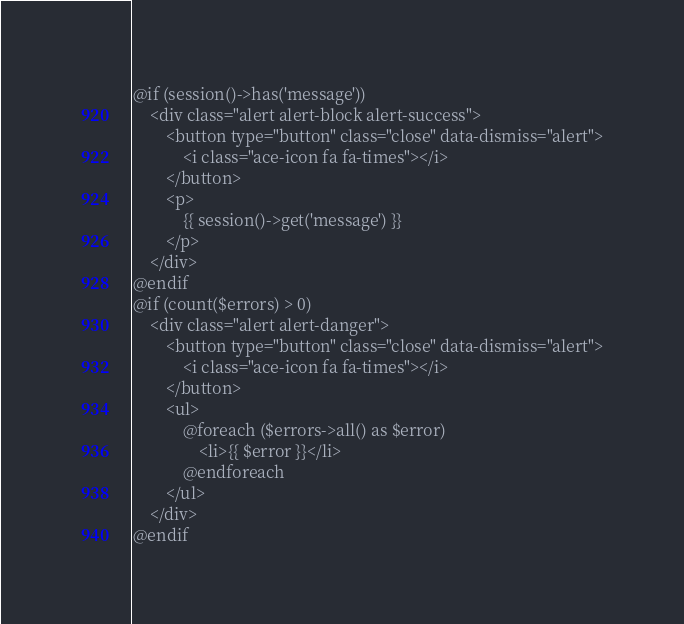<code> <loc_0><loc_0><loc_500><loc_500><_PHP_>@if (session()->has('message'))
    <div class="alert alert-block alert-success">
        <button type="button" class="close" data-dismiss="alert">
            <i class="ace-icon fa fa-times"></i>
        </button>
        <p>
            {{ session()->get('message') }}
        </p>
    </div>
@endif
@if (count($errors) > 0)
    <div class="alert alert-danger">
        <button type="button" class="close" data-dismiss="alert">
            <i class="ace-icon fa fa-times"></i>
        </button>
        <ul>
            @foreach ($errors->all() as $error)
                <li>{{ $error }}</li>
            @endforeach
        </ul>
    </div>
@endif</code> 